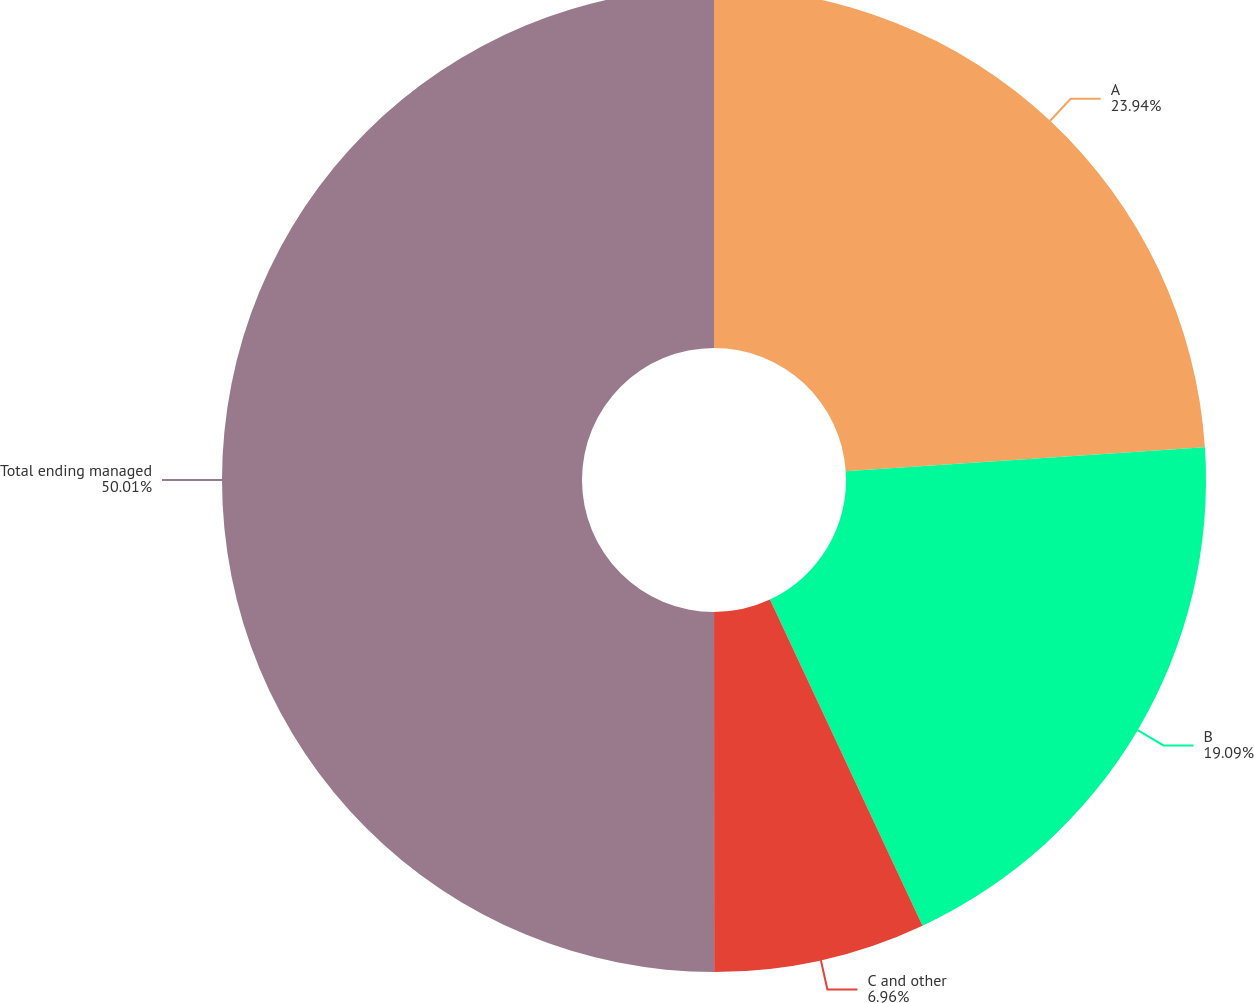Convert chart to OTSL. <chart><loc_0><loc_0><loc_500><loc_500><pie_chart><fcel>A<fcel>B<fcel>C and other<fcel>Total ending managed<nl><fcel>23.94%<fcel>19.09%<fcel>6.96%<fcel>50.0%<nl></chart> 